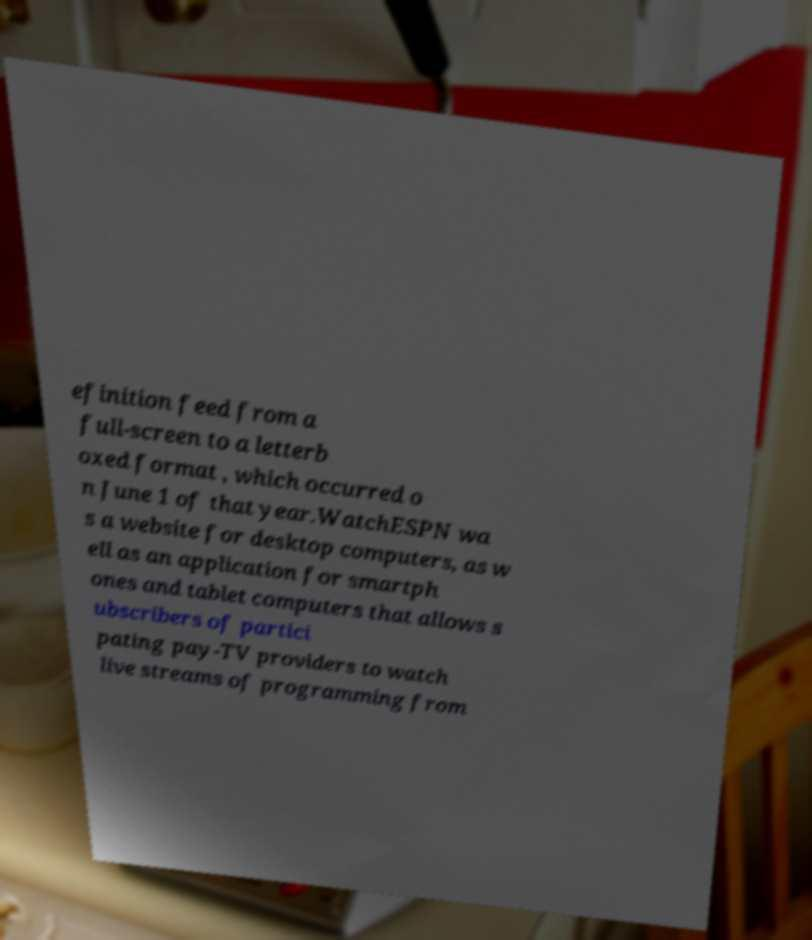Please identify and transcribe the text found in this image. efinition feed from a full-screen to a letterb oxed format , which occurred o n June 1 of that year.WatchESPN wa s a website for desktop computers, as w ell as an application for smartph ones and tablet computers that allows s ubscribers of partici pating pay-TV providers to watch live streams of programming from 